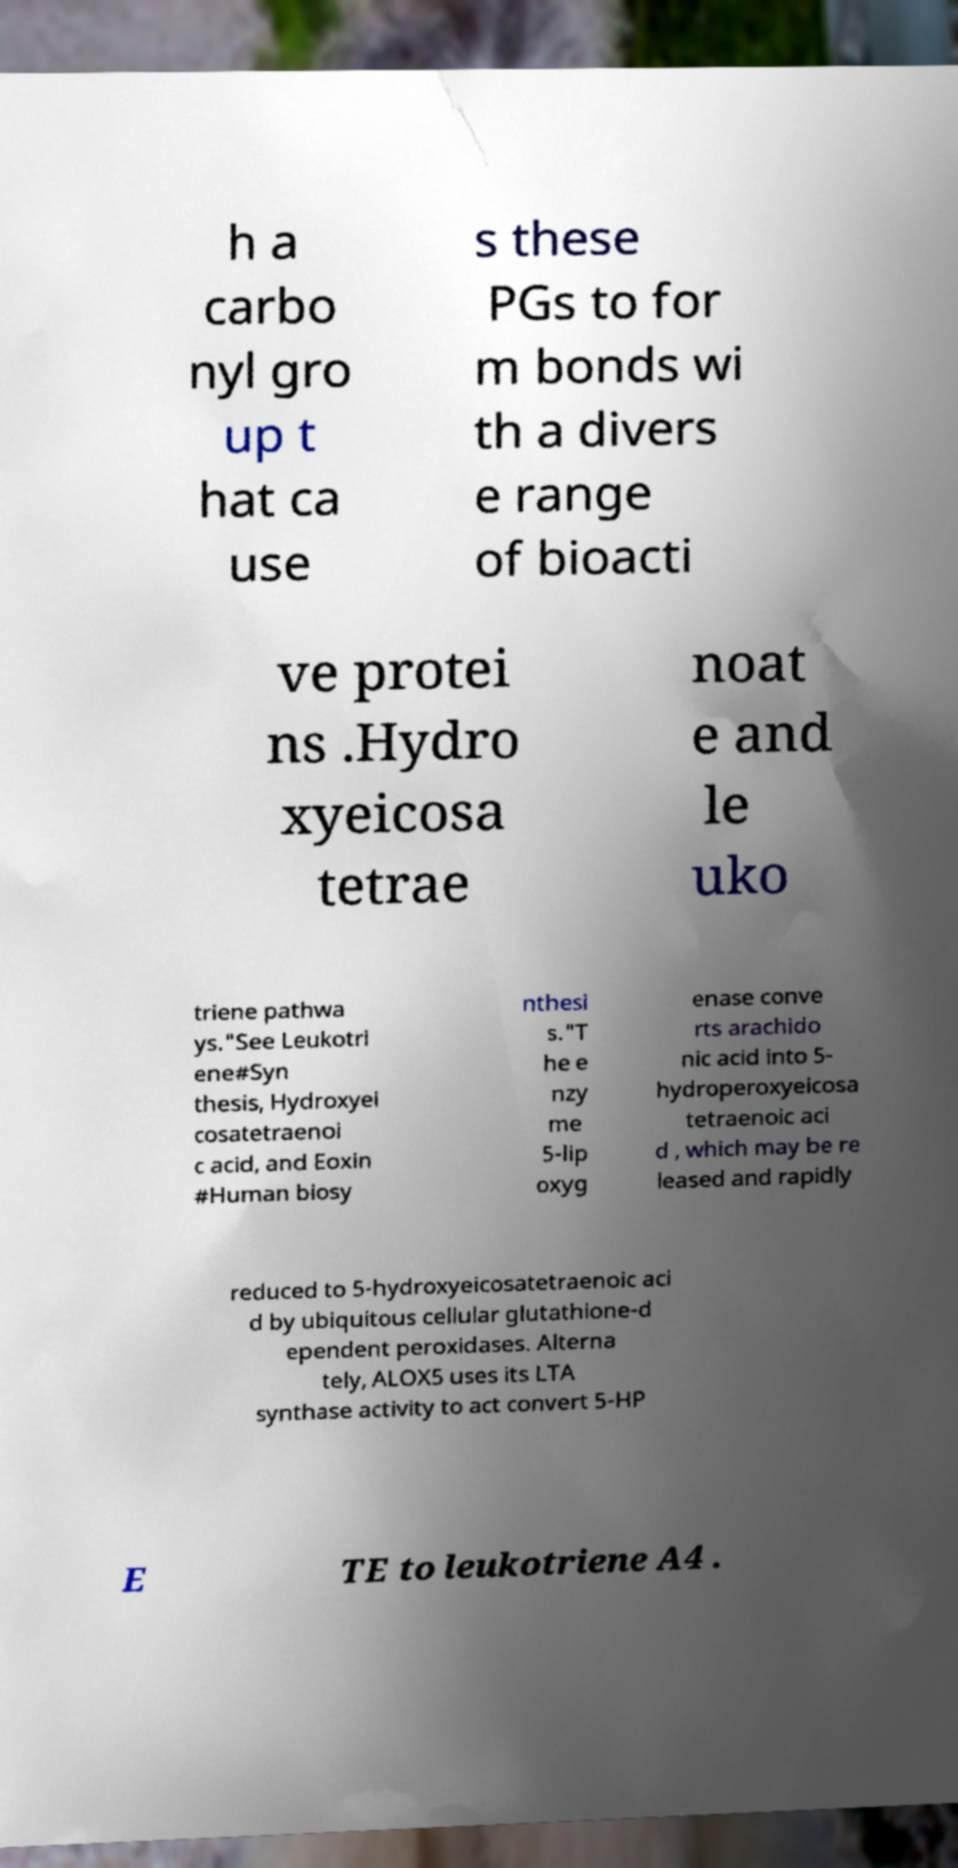What messages or text are displayed in this image? I need them in a readable, typed format. h a carbo nyl gro up t hat ca use s these PGs to for m bonds wi th a divers e range of bioacti ve protei ns .Hydro xyeicosa tetrae noat e and le uko triene pathwa ys."See Leukotri ene#Syn thesis, Hydroxyei cosatetraenoi c acid, and Eoxin #Human biosy nthesi s."T he e nzy me 5-lip oxyg enase conve rts arachido nic acid into 5- hydroperoxyeicosa tetraenoic aci d , which may be re leased and rapidly reduced to 5-hydroxyeicosatetraenoic aci d by ubiquitous cellular glutathione-d ependent peroxidases. Alterna tely, ALOX5 uses its LTA synthase activity to act convert 5-HP E TE to leukotriene A4 . 